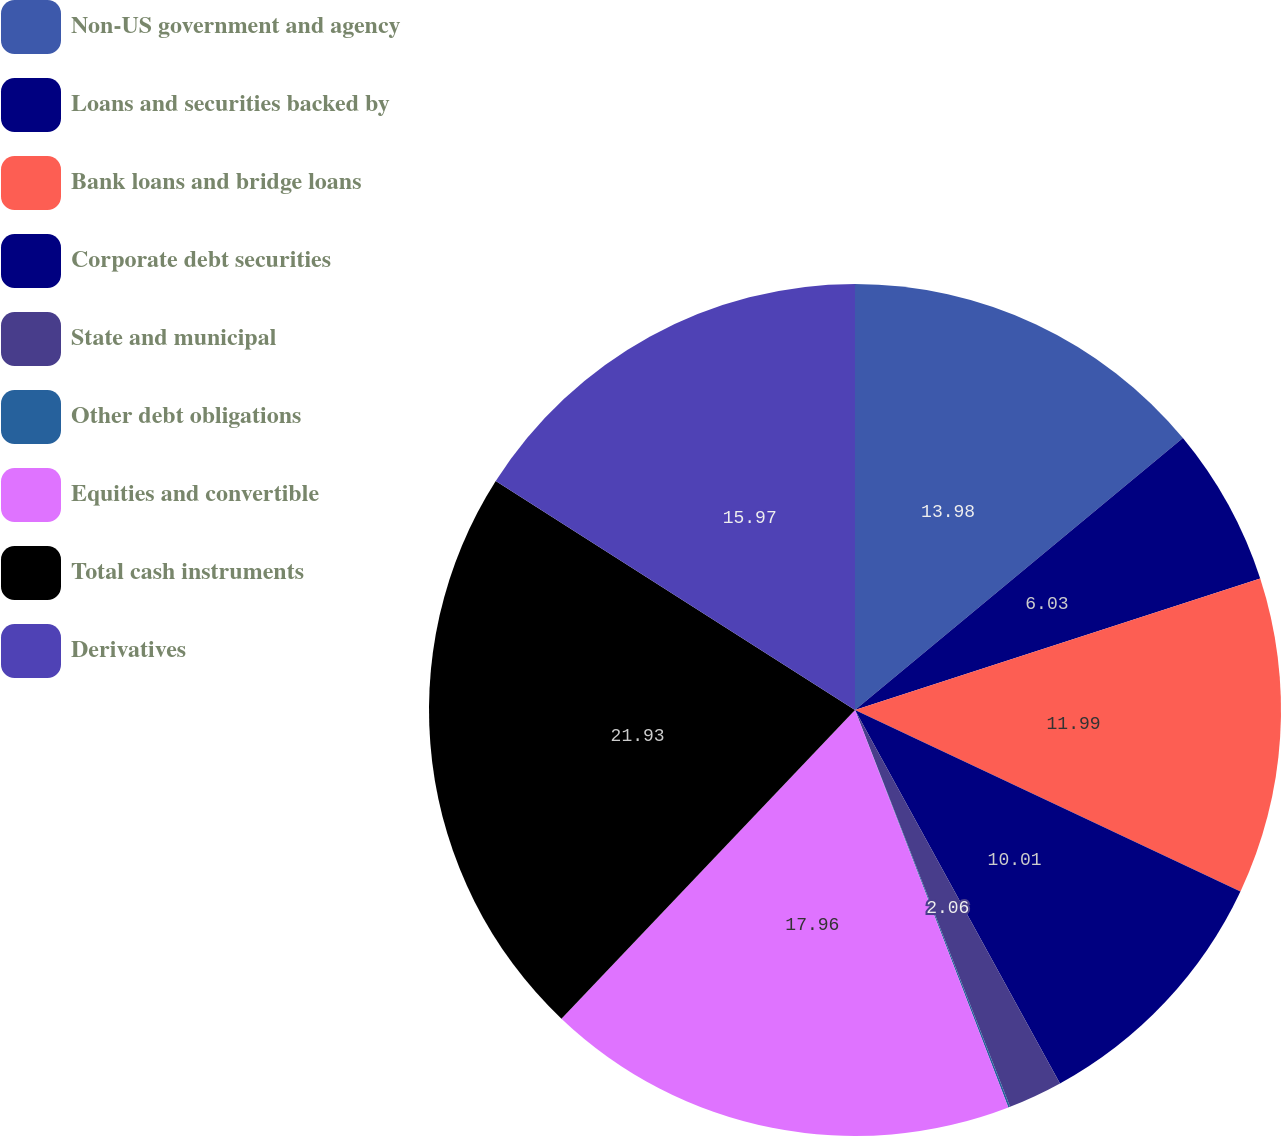<chart> <loc_0><loc_0><loc_500><loc_500><pie_chart><fcel>Non-US government and agency<fcel>Loans and securities backed by<fcel>Bank loans and bridge loans<fcel>Corporate debt securities<fcel>State and municipal<fcel>Other debt obligations<fcel>Equities and convertible<fcel>Total cash instruments<fcel>Derivatives<nl><fcel>13.98%<fcel>6.03%<fcel>11.99%<fcel>10.01%<fcel>2.06%<fcel>0.07%<fcel>17.96%<fcel>21.93%<fcel>15.97%<nl></chart> 